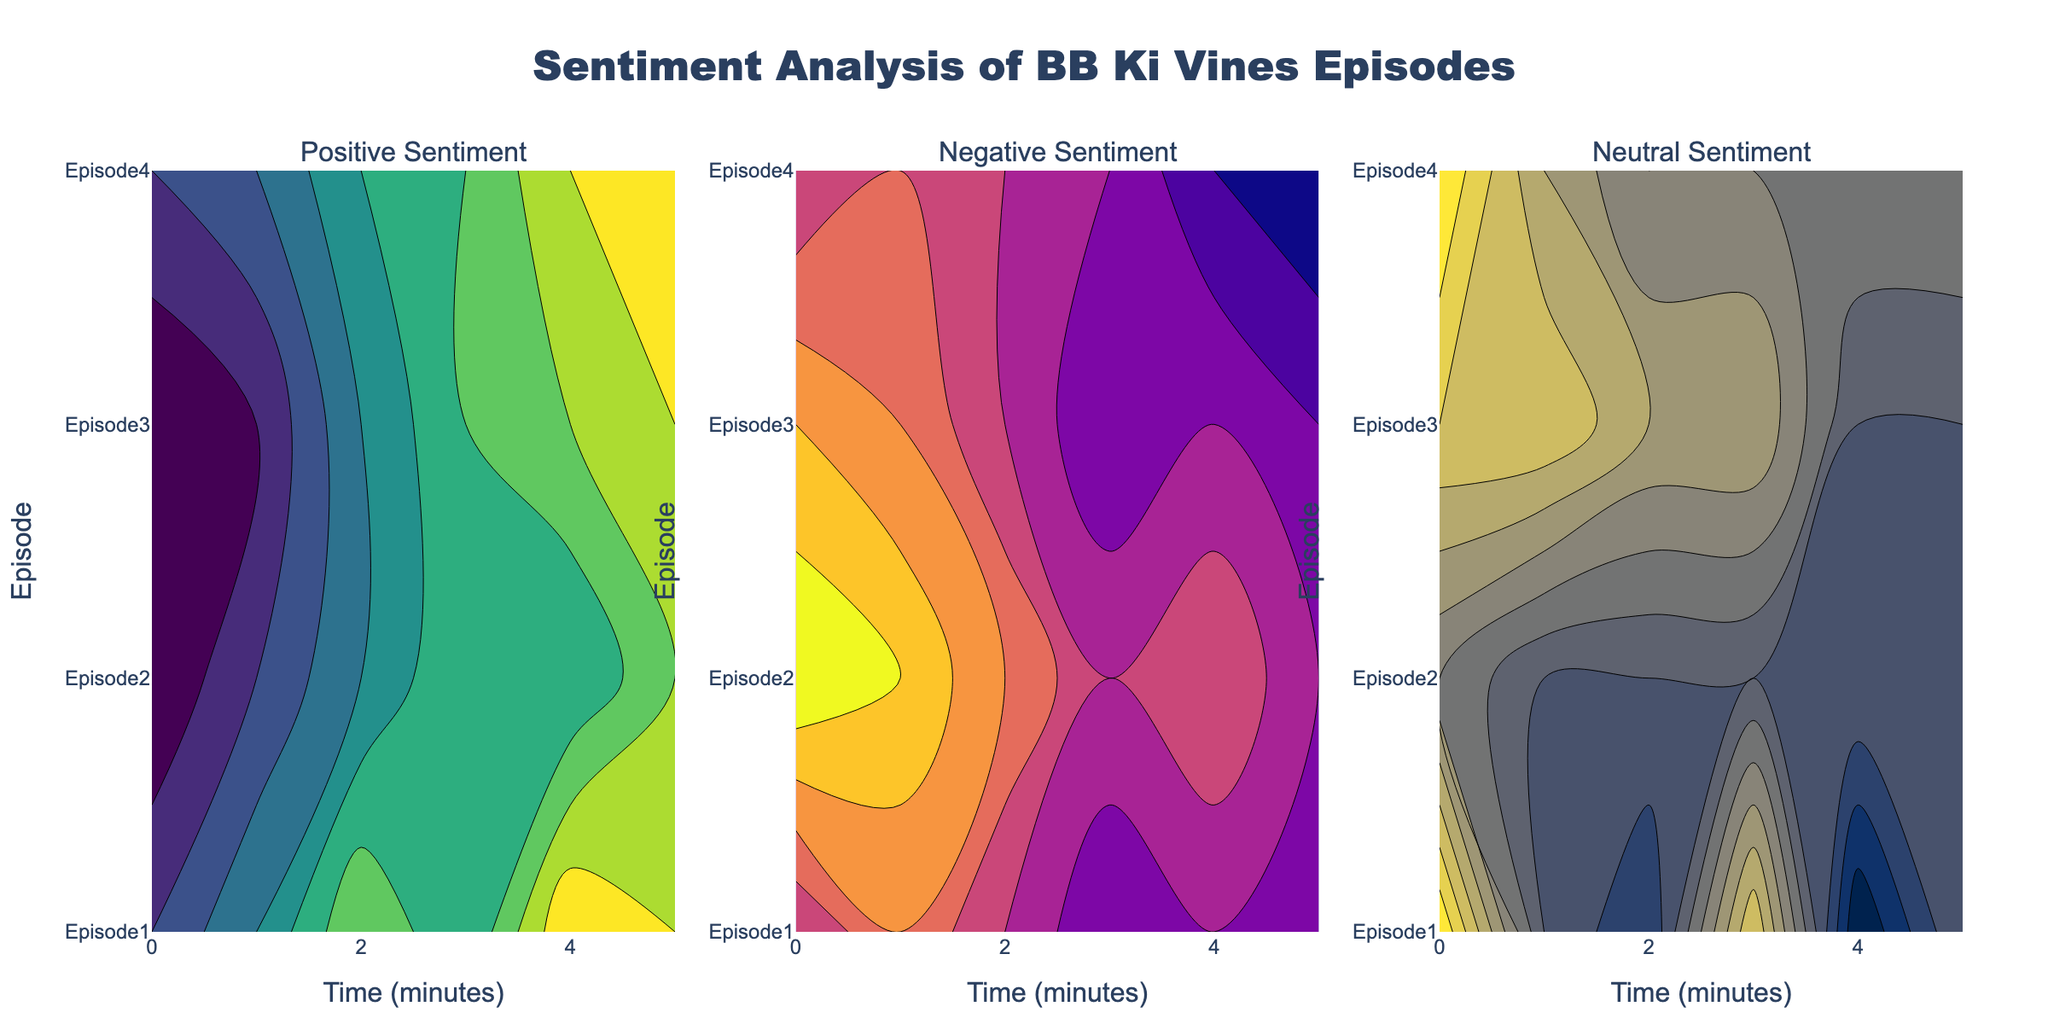What is the plot title? The plot title is displayed at the top center of the figure. It reads "Sentiment Analysis of BB Ki Vines Episodes".
Answer: Sentiment Analysis of BB Ki Vines Episodes What are the x and y-axis labels? The x-axis label is displayed at the bottom of the plot, and it reads "Time (minutes)". The y-axis label is on the left side of the plot, and it reads "Episode".
Answer: x-axis: Time (minutes), y-axis: Episode How many episodes are included in the analysis? From the y-axis ticks, we can see that there are four episodes included in the analysis.
Answer: 4 Which sentiment type shows the greatest variation over time across all episodes? By examining the color density and variation across the contour plots, "Negative Sentiment" shows the greatest variation, as evident by more gradient changes in its contour plot compared to "Positive Sentiment" and "Neutral Sentiment".
Answer: Negative Sentiment Which episode has the highest average positive sentiment over the duration? Episode 1 shows the highest levels of positive sentiment consistently across the different times, which can be inferred from the denser and higher-value contour lines in the "Positive Sentiment" plot.
Answer: Episode 1 At which time point do episodes 1 and 2 show their peak positive sentiment? Both episode 1 and episode 2 show their peak positive sentiment at the 4-minute mark, as indicated by the highest contour levels in the "Positive Sentiment" plot.
Answer: 4 minutes How does the neutral sentiment in episode 4 at 5 minutes compare to the neutral sentiment in episode 2 at the same time? The neutral sentiment in episode 4 at 5 minutes has a contour value closer to the higher end of the color scale, while episode 2 at 5 minutes has a consistently lower neutral sentiment, indicating episode 4 has a higher neutral sentiment at this time point.
Answer: Higher Between episode 1 and episode 3, which one has a lower maximum negative sentiment? By examining the "Negative Sentiment" plot, the contour lines for episode 1 are uniformly lower compared to episode 3, indicating that episode 1 has a lower maximum negative sentiment.
Answer: Episode 1 What overall trend can be observed in the positive sentiment for each subsequent episode over time? By looking at the "Positive Sentiment" plot, each subsequent episode generally shows an increasing trend in positive sentiment, with later episodes starting at a slightly lower sentiment but increasing more steadily over time.
Answer: Increasing trend 